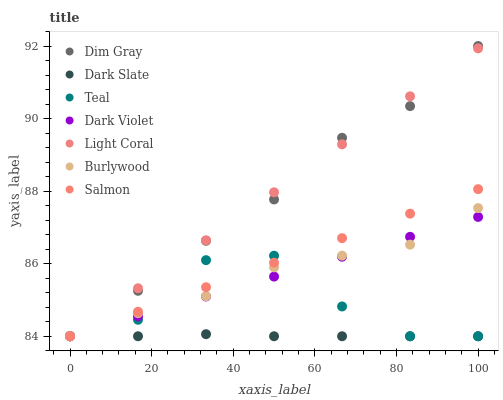Does Dark Slate have the minimum area under the curve?
Answer yes or no. Yes. Does Light Coral have the maximum area under the curve?
Answer yes or no. Yes. Does Burlywood have the minimum area under the curve?
Answer yes or no. No. Does Burlywood have the maximum area under the curve?
Answer yes or no. No. Is Salmon the smoothest?
Answer yes or no. Yes. Is Teal the roughest?
Answer yes or no. Yes. Is Burlywood the smoothest?
Answer yes or no. No. Is Burlywood the roughest?
Answer yes or no. No. Does Dim Gray have the lowest value?
Answer yes or no. Yes. Does Dim Gray have the highest value?
Answer yes or no. Yes. Does Burlywood have the highest value?
Answer yes or no. No. Does Teal intersect Light Coral?
Answer yes or no. Yes. Is Teal less than Light Coral?
Answer yes or no. No. Is Teal greater than Light Coral?
Answer yes or no. No. 